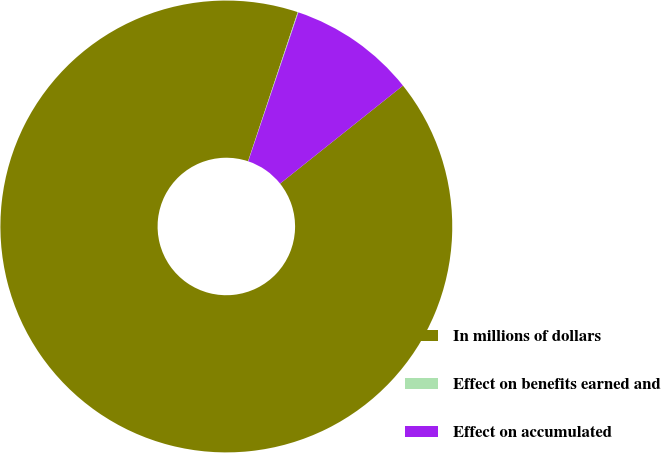Convert chart to OTSL. <chart><loc_0><loc_0><loc_500><loc_500><pie_chart><fcel>In millions of dollars<fcel>Effect on benefits earned and<fcel>Effect on accumulated<nl><fcel>90.83%<fcel>0.05%<fcel>9.12%<nl></chart> 